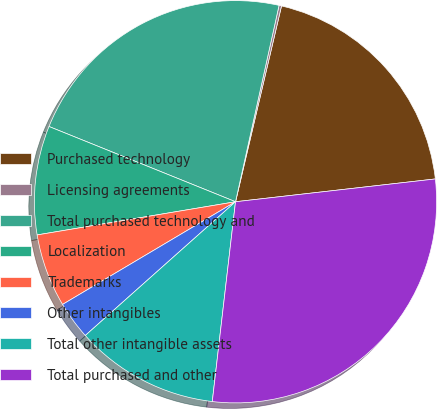Convert chart. <chart><loc_0><loc_0><loc_500><loc_500><pie_chart><fcel>Purchased technology<fcel>Licensing agreements<fcel>Total purchased technology and<fcel>Localization<fcel>Trademarks<fcel>Other intangibles<fcel>Total other intangible assets<fcel>Total purchased and other<nl><fcel>19.52%<fcel>0.2%<fcel>22.37%<fcel>8.74%<fcel>5.89%<fcel>3.05%<fcel>11.58%<fcel>28.65%<nl></chart> 